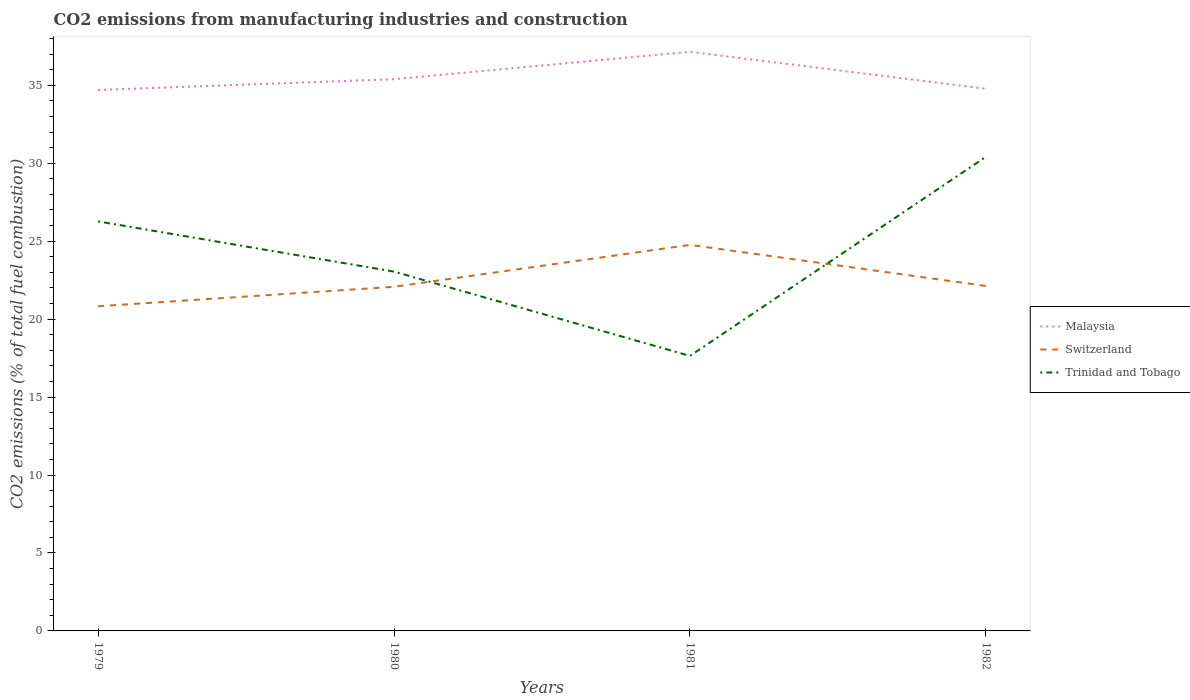Across all years, what is the maximum amount of CO2 emitted in Malaysia?
Ensure brevity in your answer.  34.7. In which year was the amount of CO2 emitted in Malaysia maximum?
Your answer should be compact. 1979. What is the total amount of CO2 emitted in Switzerland in the graph?
Keep it short and to the point. -3.94. What is the difference between the highest and the second highest amount of CO2 emitted in Switzerland?
Offer a very short reply. 3.94. What is the difference between the highest and the lowest amount of CO2 emitted in Malaysia?
Your answer should be compact. 1. Is the amount of CO2 emitted in Malaysia strictly greater than the amount of CO2 emitted in Switzerland over the years?
Offer a terse response. No. How many lines are there?
Keep it short and to the point. 3. How many years are there in the graph?
Offer a very short reply. 4. What is the difference between two consecutive major ticks on the Y-axis?
Offer a terse response. 5. How many legend labels are there?
Your answer should be very brief. 3. How are the legend labels stacked?
Your answer should be compact. Vertical. What is the title of the graph?
Offer a very short reply. CO2 emissions from manufacturing industries and construction. What is the label or title of the Y-axis?
Give a very brief answer. CO2 emissions (% of total fuel combustion). What is the CO2 emissions (% of total fuel combustion) in Malaysia in 1979?
Your answer should be compact. 34.7. What is the CO2 emissions (% of total fuel combustion) of Switzerland in 1979?
Keep it short and to the point. 20.82. What is the CO2 emissions (% of total fuel combustion) in Trinidad and Tobago in 1979?
Provide a succinct answer. 26.27. What is the CO2 emissions (% of total fuel combustion) of Malaysia in 1980?
Provide a short and direct response. 35.39. What is the CO2 emissions (% of total fuel combustion) of Switzerland in 1980?
Keep it short and to the point. 22.07. What is the CO2 emissions (% of total fuel combustion) of Trinidad and Tobago in 1980?
Provide a short and direct response. 23.05. What is the CO2 emissions (% of total fuel combustion) of Malaysia in 1981?
Your response must be concise. 37.15. What is the CO2 emissions (% of total fuel combustion) of Switzerland in 1981?
Offer a very short reply. 24.76. What is the CO2 emissions (% of total fuel combustion) of Trinidad and Tobago in 1981?
Provide a short and direct response. 17.64. What is the CO2 emissions (% of total fuel combustion) in Malaysia in 1982?
Your answer should be compact. 34.78. What is the CO2 emissions (% of total fuel combustion) of Switzerland in 1982?
Offer a terse response. 22.13. What is the CO2 emissions (% of total fuel combustion) of Trinidad and Tobago in 1982?
Offer a very short reply. 30.41. Across all years, what is the maximum CO2 emissions (% of total fuel combustion) in Malaysia?
Keep it short and to the point. 37.15. Across all years, what is the maximum CO2 emissions (% of total fuel combustion) in Switzerland?
Offer a very short reply. 24.76. Across all years, what is the maximum CO2 emissions (% of total fuel combustion) in Trinidad and Tobago?
Ensure brevity in your answer.  30.41. Across all years, what is the minimum CO2 emissions (% of total fuel combustion) in Malaysia?
Offer a terse response. 34.7. Across all years, what is the minimum CO2 emissions (% of total fuel combustion) of Switzerland?
Offer a very short reply. 20.82. Across all years, what is the minimum CO2 emissions (% of total fuel combustion) in Trinidad and Tobago?
Make the answer very short. 17.64. What is the total CO2 emissions (% of total fuel combustion) of Malaysia in the graph?
Provide a short and direct response. 142.01. What is the total CO2 emissions (% of total fuel combustion) in Switzerland in the graph?
Offer a very short reply. 89.79. What is the total CO2 emissions (% of total fuel combustion) in Trinidad and Tobago in the graph?
Make the answer very short. 97.37. What is the difference between the CO2 emissions (% of total fuel combustion) in Malaysia in 1979 and that in 1980?
Give a very brief answer. -0.69. What is the difference between the CO2 emissions (% of total fuel combustion) of Switzerland in 1979 and that in 1980?
Provide a succinct answer. -1.25. What is the difference between the CO2 emissions (% of total fuel combustion) of Trinidad and Tobago in 1979 and that in 1980?
Provide a short and direct response. 3.22. What is the difference between the CO2 emissions (% of total fuel combustion) of Malaysia in 1979 and that in 1981?
Make the answer very short. -2.45. What is the difference between the CO2 emissions (% of total fuel combustion) in Switzerland in 1979 and that in 1981?
Your answer should be compact. -3.94. What is the difference between the CO2 emissions (% of total fuel combustion) in Trinidad and Tobago in 1979 and that in 1981?
Provide a short and direct response. 8.63. What is the difference between the CO2 emissions (% of total fuel combustion) of Malaysia in 1979 and that in 1982?
Offer a terse response. -0.08. What is the difference between the CO2 emissions (% of total fuel combustion) in Switzerland in 1979 and that in 1982?
Make the answer very short. -1.3. What is the difference between the CO2 emissions (% of total fuel combustion) in Trinidad and Tobago in 1979 and that in 1982?
Ensure brevity in your answer.  -4.14. What is the difference between the CO2 emissions (% of total fuel combustion) in Malaysia in 1980 and that in 1981?
Offer a very short reply. -1.76. What is the difference between the CO2 emissions (% of total fuel combustion) in Switzerland in 1980 and that in 1981?
Provide a succinct answer. -2.69. What is the difference between the CO2 emissions (% of total fuel combustion) of Trinidad and Tobago in 1980 and that in 1981?
Your response must be concise. 5.41. What is the difference between the CO2 emissions (% of total fuel combustion) in Malaysia in 1980 and that in 1982?
Offer a very short reply. 0.61. What is the difference between the CO2 emissions (% of total fuel combustion) of Switzerland in 1980 and that in 1982?
Offer a terse response. -0.05. What is the difference between the CO2 emissions (% of total fuel combustion) in Trinidad and Tobago in 1980 and that in 1982?
Your answer should be very brief. -7.36. What is the difference between the CO2 emissions (% of total fuel combustion) in Malaysia in 1981 and that in 1982?
Give a very brief answer. 2.37. What is the difference between the CO2 emissions (% of total fuel combustion) of Switzerland in 1981 and that in 1982?
Provide a succinct answer. 2.64. What is the difference between the CO2 emissions (% of total fuel combustion) in Trinidad and Tobago in 1981 and that in 1982?
Your answer should be compact. -12.77. What is the difference between the CO2 emissions (% of total fuel combustion) of Malaysia in 1979 and the CO2 emissions (% of total fuel combustion) of Switzerland in 1980?
Your answer should be very brief. 12.62. What is the difference between the CO2 emissions (% of total fuel combustion) in Malaysia in 1979 and the CO2 emissions (% of total fuel combustion) in Trinidad and Tobago in 1980?
Ensure brevity in your answer.  11.65. What is the difference between the CO2 emissions (% of total fuel combustion) in Switzerland in 1979 and the CO2 emissions (% of total fuel combustion) in Trinidad and Tobago in 1980?
Offer a very short reply. -2.22. What is the difference between the CO2 emissions (% of total fuel combustion) of Malaysia in 1979 and the CO2 emissions (% of total fuel combustion) of Switzerland in 1981?
Ensure brevity in your answer.  9.93. What is the difference between the CO2 emissions (% of total fuel combustion) in Malaysia in 1979 and the CO2 emissions (% of total fuel combustion) in Trinidad and Tobago in 1981?
Ensure brevity in your answer.  17.06. What is the difference between the CO2 emissions (% of total fuel combustion) of Switzerland in 1979 and the CO2 emissions (% of total fuel combustion) of Trinidad and Tobago in 1981?
Give a very brief answer. 3.18. What is the difference between the CO2 emissions (% of total fuel combustion) in Malaysia in 1979 and the CO2 emissions (% of total fuel combustion) in Switzerland in 1982?
Provide a short and direct response. 12.57. What is the difference between the CO2 emissions (% of total fuel combustion) in Malaysia in 1979 and the CO2 emissions (% of total fuel combustion) in Trinidad and Tobago in 1982?
Provide a short and direct response. 4.29. What is the difference between the CO2 emissions (% of total fuel combustion) of Switzerland in 1979 and the CO2 emissions (% of total fuel combustion) of Trinidad and Tobago in 1982?
Ensure brevity in your answer.  -9.59. What is the difference between the CO2 emissions (% of total fuel combustion) of Malaysia in 1980 and the CO2 emissions (% of total fuel combustion) of Switzerland in 1981?
Ensure brevity in your answer.  10.63. What is the difference between the CO2 emissions (% of total fuel combustion) in Malaysia in 1980 and the CO2 emissions (% of total fuel combustion) in Trinidad and Tobago in 1981?
Your answer should be very brief. 17.75. What is the difference between the CO2 emissions (% of total fuel combustion) in Switzerland in 1980 and the CO2 emissions (% of total fuel combustion) in Trinidad and Tobago in 1981?
Ensure brevity in your answer.  4.43. What is the difference between the CO2 emissions (% of total fuel combustion) in Malaysia in 1980 and the CO2 emissions (% of total fuel combustion) in Switzerland in 1982?
Your answer should be compact. 13.26. What is the difference between the CO2 emissions (% of total fuel combustion) in Malaysia in 1980 and the CO2 emissions (% of total fuel combustion) in Trinidad and Tobago in 1982?
Provide a succinct answer. 4.98. What is the difference between the CO2 emissions (% of total fuel combustion) in Switzerland in 1980 and the CO2 emissions (% of total fuel combustion) in Trinidad and Tobago in 1982?
Give a very brief answer. -8.34. What is the difference between the CO2 emissions (% of total fuel combustion) in Malaysia in 1981 and the CO2 emissions (% of total fuel combustion) in Switzerland in 1982?
Provide a succinct answer. 15.02. What is the difference between the CO2 emissions (% of total fuel combustion) in Malaysia in 1981 and the CO2 emissions (% of total fuel combustion) in Trinidad and Tobago in 1982?
Keep it short and to the point. 6.74. What is the difference between the CO2 emissions (% of total fuel combustion) in Switzerland in 1981 and the CO2 emissions (% of total fuel combustion) in Trinidad and Tobago in 1982?
Your response must be concise. -5.65. What is the average CO2 emissions (% of total fuel combustion) of Malaysia per year?
Provide a short and direct response. 35.5. What is the average CO2 emissions (% of total fuel combustion) of Switzerland per year?
Offer a terse response. 22.45. What is the average CO2 emissions (% of total fuel combustion) in Trinidad and Tobago per year?
Offer a terse response. 24.34. In the year 1979, what is the difference between the CO2 emissions (% of total fuel combustion) of Malaysia and CO2 emissions (% of total fuel combustion) of Switzerland?
Keep it short and to the point. 13.87. In the year 1979, what is the difference between the CO2 emissions (% of total fuel combustion) of Malaysia and CO2 emissions (% of total fuel combustion) of Trinidad and Tobago?
Your answer should be compact. 8.43. In the year 1979, what is the difference between the CO2 emissions (% of total fuel combustion) in Switzerland and CO2 emissions (% of total fuel combustion) in Trinidad and Tobago?
Give a very brief answer. -5.44. In the year 1980, what is the difference between the CO2 emissions (% of total fuel combustion) of Malaysia and CO2 emissions (% of total fuel combustion) of Switzerland?
Your response must be concise. 13.32. In the year 1980, what is the difference between the CO2 emissions (% of total fuel combustion) in Malaysia and CO2 emissions (% of total fuel combustion) in Trinidad and Tobago?
Make the answer very short. 12.34. In the year 1980, what is the difference between the CO2 emissions (% of total fuel combustion) in Switzerland and CO2 emissions (% of total fuel combustion) in Trinidad and Tobago?
Your answer should be very brief. -0.97. In the year 1981, what is the difference between the CO2 emissions (% of total fuel combustion) in Malaysia and CO2 emissions (% of total fuel combustion) in Switzerland?
Ensure brevity in your answer.  12.39. In the year 1981, what is the difference between the CO2 emissions (% of total fuel combustion) of Malaysia and CO2 emissions (% of total fuel combustion) of Trinidad and Tobago?
Make the answer very short. 19.51. In the year 1981, what is the difference between the CO2 emissions (% of total fuel combustion) of Switzerland and CO2 emissions (% of total fuel combustion) of Trinidad and Tobago?
Your answer should be very brief. 7.12. In the year 1982, what is the difference between the CO2 emissions (% of total fuel combustion) of Malaysia and CO2 emissions (% of total fuel combustion) of Switzerland?
Provide a short and direct response. 12.65. In the year 1982, what is the difference between the CO2 emissions (% of total fuel combustion) in Malaysia and CO2 emissions (% of total fuel combustion) in Trinidad and Tobago?
Provide a short and direct response. 4.37. In the year 1982, what is the difference between the CO2 emissions (% of total fuel combustion) of Switzerland and CO2 emissions (% of total fuel combustion) of Trinidad and Tobago?
Provide a succinct answer. -8.28. What is the ratio of the CO2 emissions (% of total fuel combustion) in Malaysia in 1979 to that in 1980?
Offer a terse response. 0.98. What is the ratio of the CO2 emissions (% of total fuel combustion) of Switzerland in 1979 to that in 1980?
Your response must be concise. 0.94. What is the ratio of the CO2 emissions (% of total fuel combustion) in Trinidad and Tobago in 1979 to that in 1980?
Offer a very short reply. 1.14. What is the ratio of the CO2 emissions (% of total fuel combustion) in Malaysia in 1979 to that in 1981?
Provide a short and direct response. 0.93. What is the ratio of the CO2 emissions (% of total fuel combustion) in Switzerland in 1979 to that in 1981?
Your response must be concise. 0.84. What is the ratio of the CO2 emissions (% of total fuel combustion) of Trinidad and Tobago in 1979 to that in 1981?
Your answer should be compact. 1.49. What is the ratio of the CO2 emissions (% of total fuel combustion) in Switzerland in 1979 to that in 1982?
Ensure brevity in your answer.  0.94. What is the ratio of the CO2 emissions (% of total fuel combustion) in Trinidad and Tobago in 1979 to that in 1982?
Offer a terse response. 0.86. What is the ratio of the CO2 emissions (% of total fuel combustion) of Malaysia in 1980 to that in 1981?
Your response must be concise. 0.95. What is the ratio of the CO2 emissions (% of total fuel combustion) in Switzerland in 1980 to that in 1981?
Offer a terse response. 0.89. What is the ratio of the CO2 emissions (% of total fuel combustion) of Trinidad and Tobago in 1980 to that in 1981?
Give a very brief answer. 1.31. What is the ratio of the CO2 emissions (% of total fuel combustion) of Malaysia in 1980 to that in 1982?
Provide a succinct answer. 1.02. What is the ratio of the CO2 emissions (% of total fuel combustion) in Switzerland in 1980 to that in 1982?
Ensure brevity in your answer.  1. What is the ratio of the CO2 emissions (% of total fuel combustion) of Trinidad and Tobago in 1980 to that in 1982?
Your answer should be very brief. 0.76. What is the ratio of the CO2 emissions (% of total fuel combustion) of Malaysia in 1981 to that in 1982?
Make the answer very short. 1.07. What is the ratio of the CO2 emissions (% of total fuel combustion) in Switzerland in 1981 to that in 1982?
Provide a succinct answer. 1.12. What is the ratio of the CO2 emissions (% of total fuel combustion) of Trinidad and Tobago in 1981 to that in 1982?
Ensure brevity in your answer.  0.58. What is the difference between the highest and the second highest CO2 emissions (% of total fuel combustion) in Malaysia?
Your answer should be compact. 1.76. What is the difference between the highest and the second highest CO2 emissions (% of total fuel combustion) in Switzerland?
Give a very brief answer. 2.64. What is the difference between the highest and the second highest CO2 emissions (% of total fuel combustion) of Trinidad and Tobago?
Keep it short and to the point. 4.14. What is the difference between the highest and the lowest CO2 emissions (% of total fuel combustion) in Malaysia?
Your response must be concise. 2.45. What is the difference between the highest and the lowest CO2 emissions (% of total fuel combustion) in Switzerland?
Keep it short and to the point. 3.94. What is the difference between the highest and the lowest CO2 emissions (% of total fuel combustion) in Trinidad and Tobago?
Keep it short and to the point. 12.77. 